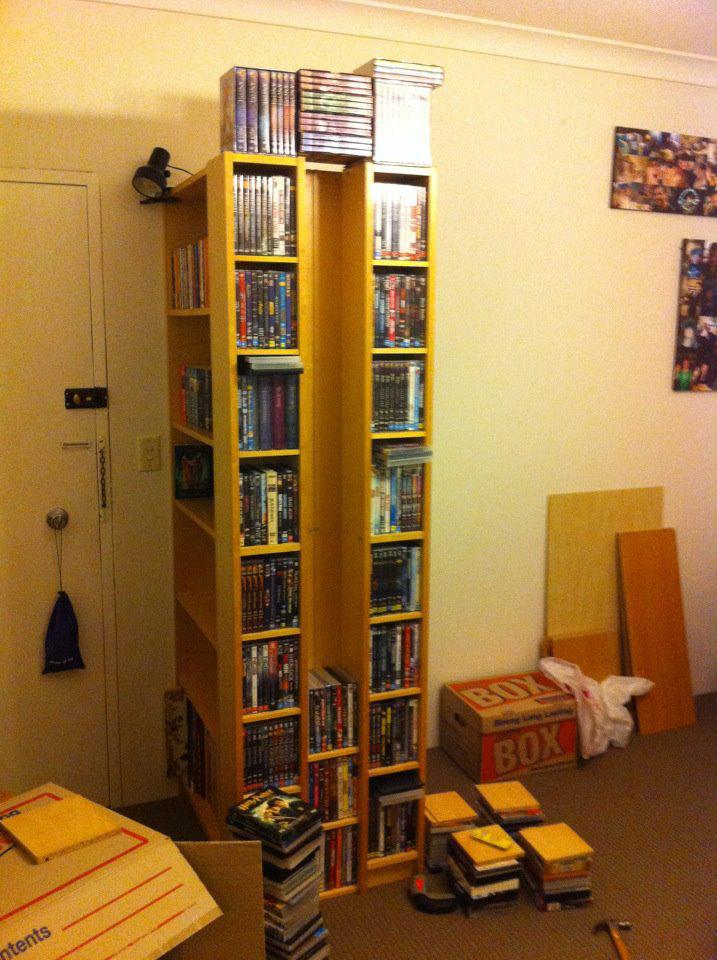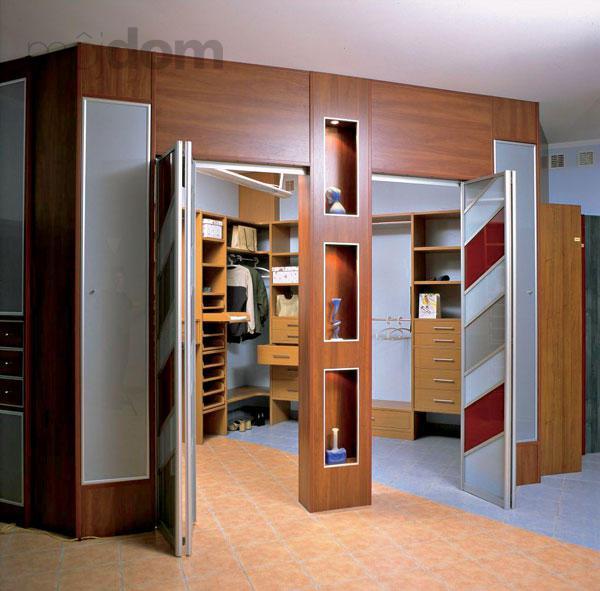The first image is the image on the left, the second image is the image on the right. Examine the images to the left and right. Is the description "Left image shows a free-standing shelf divider featuring orange color." accurate? Answer yes or no. No. The first image is the image on the left, the second image is the image on the right. Evaluate the accuracy of this statement regarding the images: "In one image, tall, colorful open shelves, that are partly orange, are used as a room divider.". Is it true? Answer yes or no. No. 